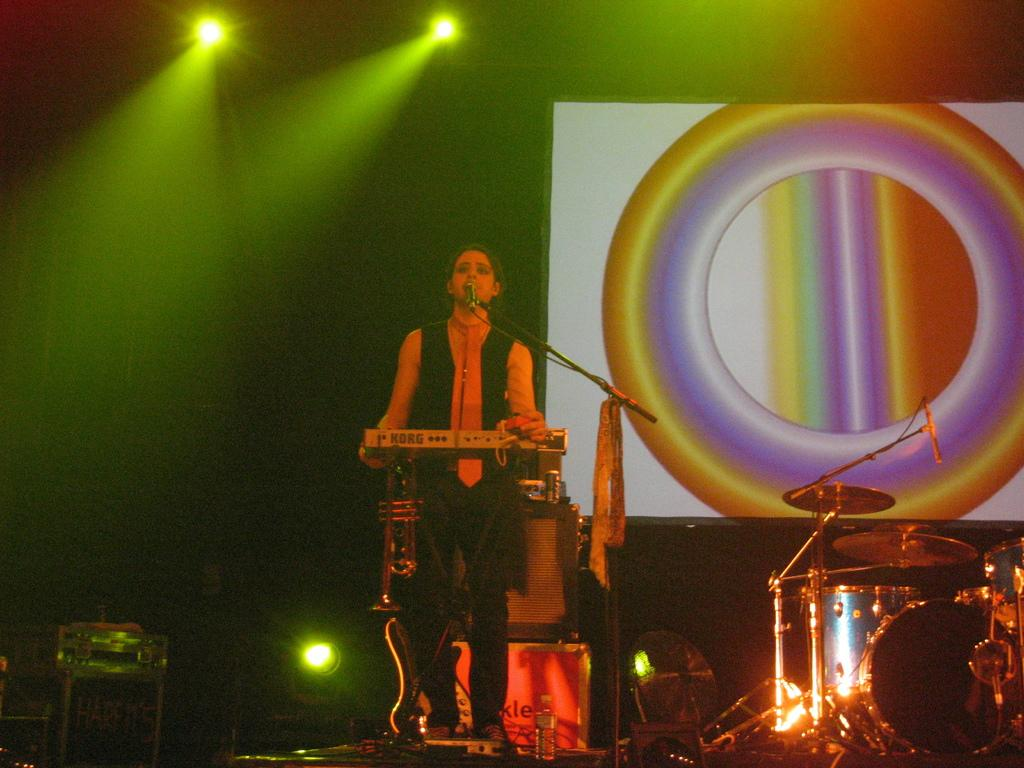What is the main feature of the image? There is a stage in the image. What is happening on the stage? A person is standing on the stage and singing. Are there any objects related to music in the image? Yes, there are musical instruments in the image. What can be seen behind the person on the stage? There are lights and a screen behind the person. What type of bird is flying across the screen in the image? There is no bird flying across the screen in the image; it only shows a person singing on stage with lights and a screen behind them. 